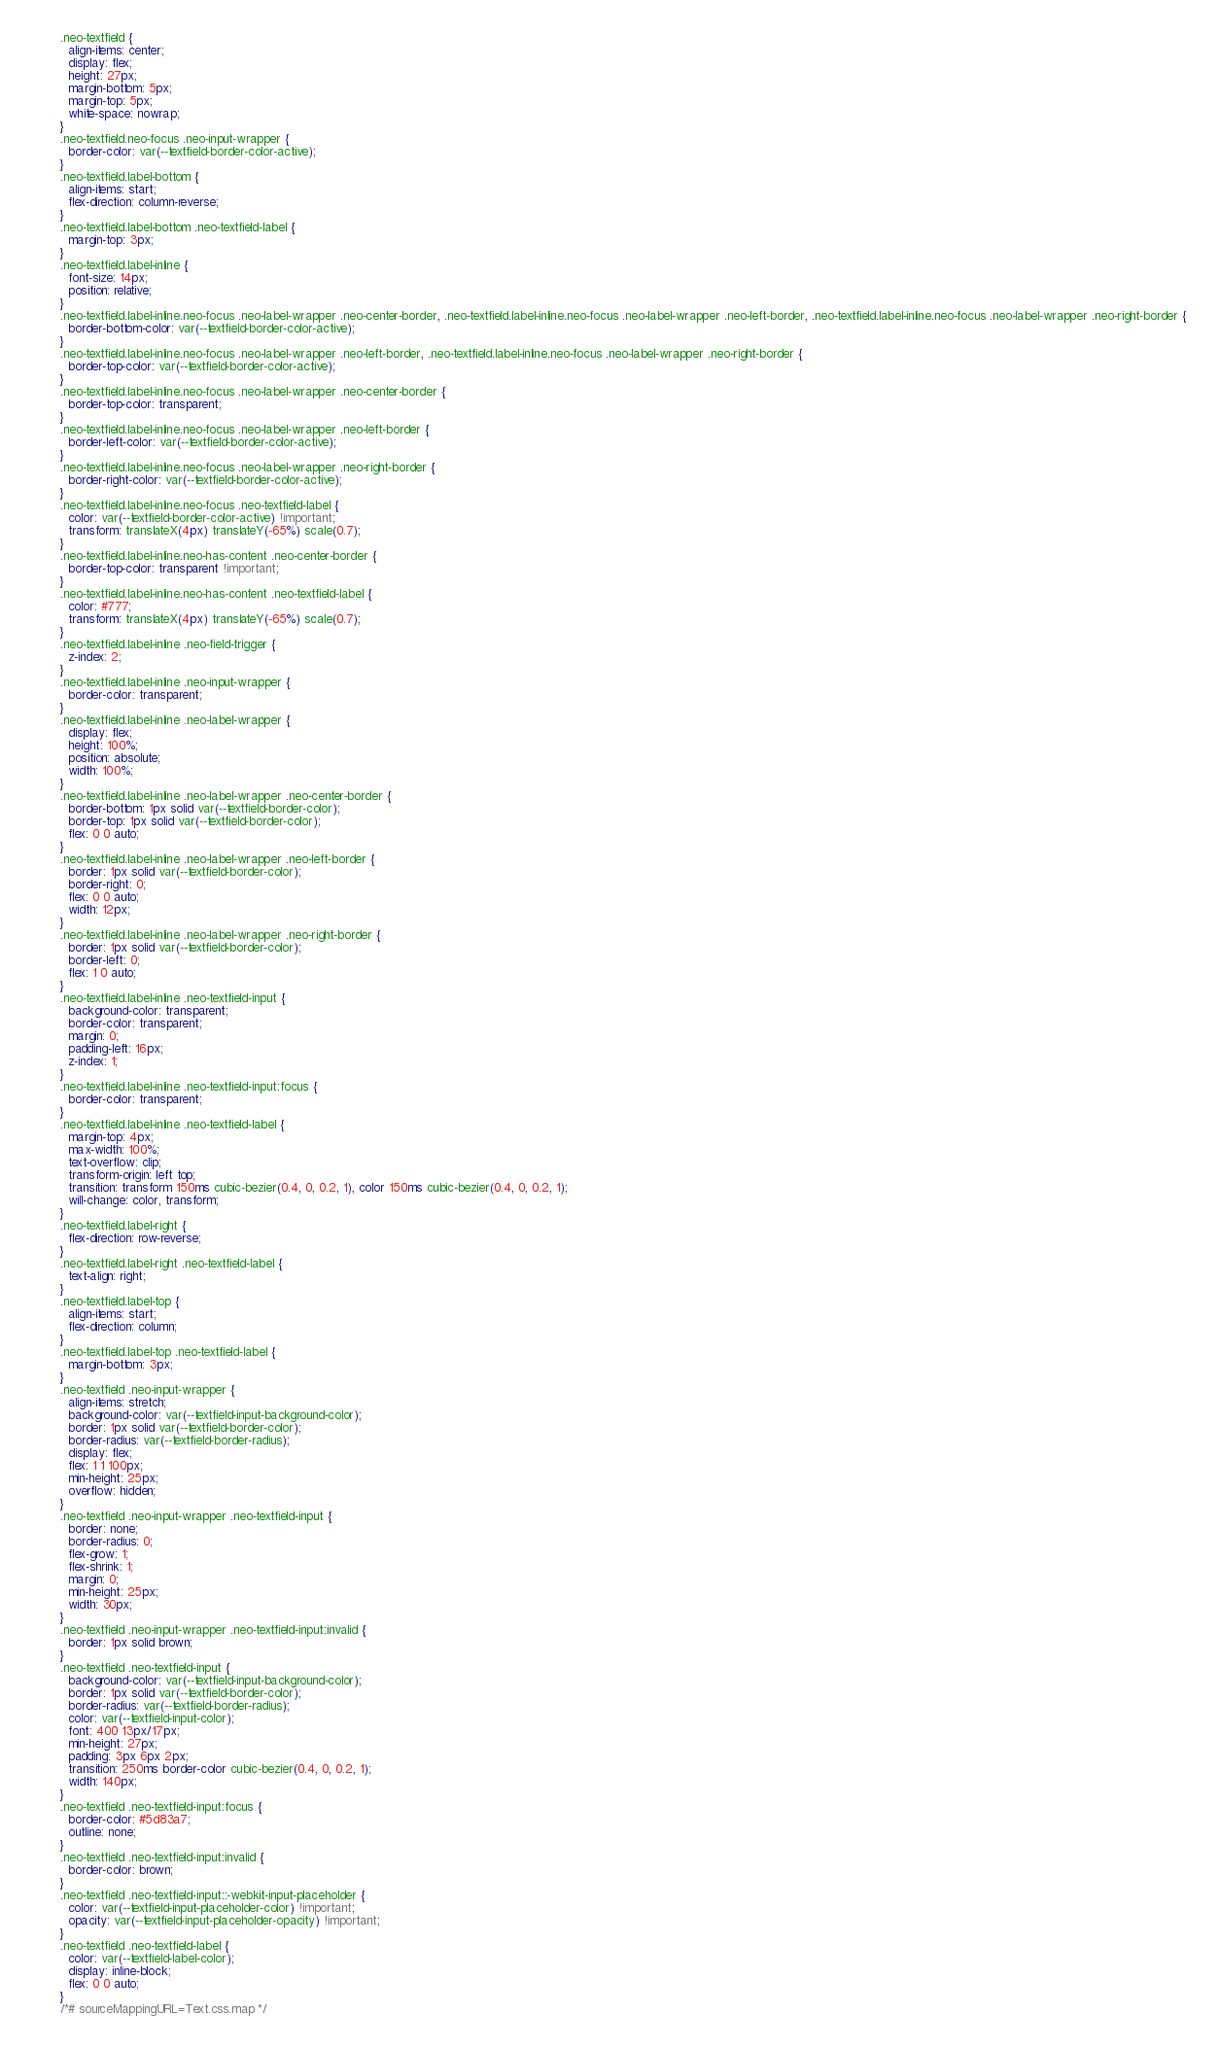Convert code to text. <code><loc_0><loc_0><loc_500><loc_500><_CSS_>.neo-textfield {
  align-items: center;
  display: flex;
  height: 27px;
  margin-bottom: 5px;
  margin-top: 5px;
  white-space: nowrap;
}
.neo-textfield.neo-focus .neo-input-wrapper {
  border-color: var(--textfield-border-color-active);
}
.neo-textfield.label-bottom {
  align-items: start;
  flex-direction: column-reverse;
}
.neo-textfield.label-bottom .neo-textfield-label {
  margin-top: 3px;
}
.neo-textfield.label-inline {
  font-size: 14px;
  position: relative;
}
.neo-textfield.label-inline.neo-focus .neo-label-wrapper .neo-center-border, .neo-textfield.label-inline.neo-focus .neo-label-wrapper .neo-left-border, .neo-textfield.label-inline.neo-focus .neo-label-wrapper .neo-right-border {
  border-bottom-color: var(--textfield-border-color-active);
}
.neo-textfield.label-inline.neo-focus .neo-label-wrapper .neo-left-border, .neo-textfield.label-inline.neo-focus .neo-label-wrapper .neo-right-border {
  border-top-color: var(--textfield-border-color-active);
}
.neo-textfield.label-inline.neo-focus .neo-label-wrapper .neo-center-border {
  border-top-color: transparent;
}
.neo-textfield.label-inline.neo-focus .neo-label-wrapper .neo-left-border {
  border-left-color: var(--textfield-border-color-active);
}
.neo-textfield.label-inline.neo-focus .neo-label-wrapper .neo-right-border {
  border-right-color: var(--textfield-border-color-active);
}
.neo-textfield.label-inline.neo-focus .neo-textfield-label {
  color: var(--textfield-border-color-active) !important;
  transform: translateX(4px) translateY(-65%) scale(0.7);
}
.neo-textfield.label-inline.neo-has-content .neo-center-border {
  border-top-color: transparent !important;
}
.neo-textfield.label-inline.neo-has-content .neo-textfield-label {
  color: #777;
  transform: translateX(4px) translateY(-65%) scale(0.7);
}
.neo-textfield.label-inline .neo-field-trigger {
  z-index: 2;
}
.neo-textfield.label-inline .neo-input-wrapper {
  border-color: transparent;
}
.neo-textfield.label-inline .neo-label-wrapper {
  display: flex;
  height: 100%;
  position: absolute;
  width: 100%;
}
.neo-textfield.label-inline .neo-label-wrapper .neo-center-border {
  border-bottom: 1px solid var(--textfield-border-color);
  border-top: 1px solid var(--textfield-border-color);
  flex: 0 0 auto;
}
.neo-textfield.label-inline .neo-label-wrapper .neo-left-border {
  border: 1px solid var(--textfield-border-color);
  border-right: 0;
  flex: 0 0 auto;
  width: 12px;
}
.neo-textfield.label-inline .neo-label-wrapper .neo-right-border {
  border: 1px solid var(--textfield-border-color);
  border-left: 0;
  flex: 1 0 auto;
}
.neo-textfield.label-inline .neo-textfield-input {
  background-color: transparent;
  border-color: transparent;
  margin: 0;
  padding-left: 16px;
  z-index: 1;
}
.neo-textfield.label-inline .neo-textfield-input:focus {
  border-color: transparent;
}
.neo-textfield.label-inline .neo-textfield-label {
  margin-top: 4px;
  max-width: 100%;
  text-overflow: clip;
  transform-origin: left top;
  transition: transform 150ms cubic-bezier(0.4, 0, 0.2, 1), color 150ms cubic-bezier(0.4, 0, 0.2, 1);
  will-change: color, transform;
}
.neo-textfield.label-right {
  flex-direction: row-reverse;
}
.neo-textfield.label-right .neo-textfield-label {
  text-align: right;
}
.neo-textfield.label-top {
  align-items: start;
  flex-direction: column;
}
.neo-textfield.label-top .neo-textfield-label {
  margin-bottom: 3px;
}
.neo-textfield .neo-input-wrapper {
  align-items: stretch;
  background-color: var(--textfield-input-background-color);
  border: 1px solid var(--textfield-border-color);
  border-radius: var(--textfield-border-radius);
  display: flex;
  flex: 1 1 100px;
  min-height: 25px;
  overflow: hidden;
}
.neo-textfield .neo-input-wrapper .neo-textfield-input {
  border: none;
  border-radius: 0;
  flex-grow: 1;
  flex-shrink: 1;
  margin: 0;
  min-height: 25px;
  width: 30px;
}
.neo-textfield .neo-input-wrapper .neo-textfield-input:invalid {
  border: 1px solid brown;
}
.neo-textfield .neo-textfield-input {
  background-color: var(--textfield-input-background-color);
  border: 1px solid var(--textfield-border-color);
  border-radius: var(--textfield-border-radius);
  color: var(--textfield-input-color);
  font: 400 13px/17px;
  min-height: 27px;
  padding: 3px 6px 2px;
  transition: 250ms border-color cubic-bezier(0.4, 0, 0.2, 1);
  width: 140px;
}
.neo-textfield .neo-textfield-input:focus {
  border-color: #5d83a7;
  outline: none;
}
.neo-textfield .neo-textfield-input:invalid {
  border-color: brown;
}
.neo-textfield .neo-textfield-input::-webkit-input-placeholder {
  color: var(--textfield-input-placeholder-color) !important;
  opacity: var(--textfield-input-placeholder-opacity) !important;
}
.neo-textfield .neo-textfield-label {
  color: var(--textfield-label-color);
  display: inline-block;
  flex: 0 0 auto;
}
/*# sourceMappingURL=Text.css.map */</code> 